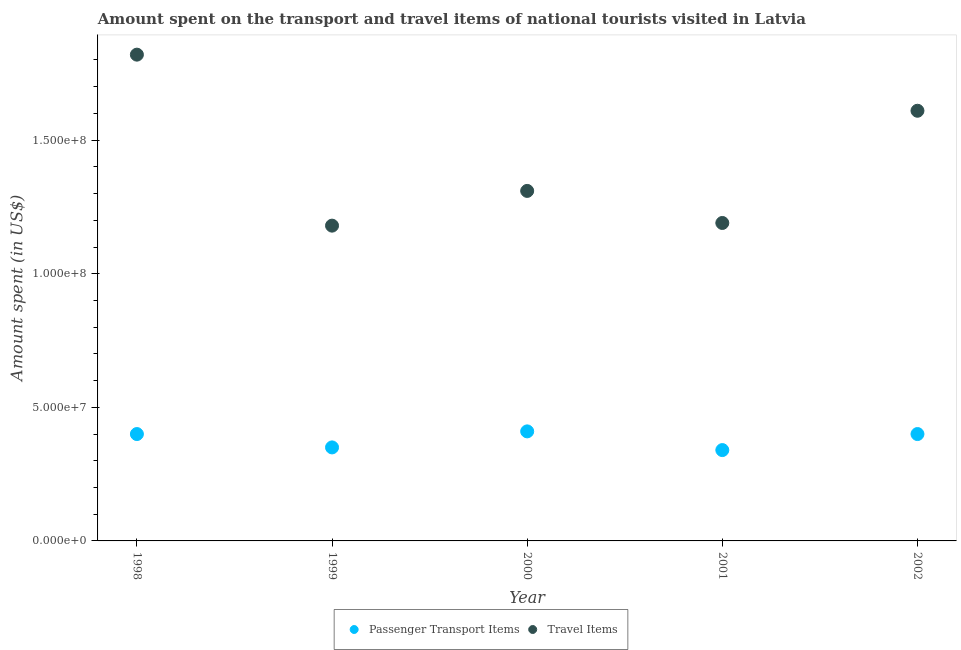How many different coloured dotlines are there?
Ensure brevity in your answer.  2. Is the number of dotlines equal to the number of legend labels?
Offer a terse response. Yes. What is the amount spent on passenger transport items in 2000?
Keep it short and to the point. 4.10e+07. Across all years, what is the maximum amount spent on passenger transport items?
Keep it short and to the point. 4.10e+07. Across all years, what is the minimum amount spent on passenger transport items?
Provide a succinct answer. 3.40e+07. What is the total amount spent on passenger transport items in the graph?
Your answer should be very brief. 1.90e+08. What is the difference between the amount spent on passenger transport items in 1999 and that in 2002?
Your response must be concise. -5.00e+06. What is the difference between the amount spent on passenger transport items in 2001 and the amount spent in travel items in 2002?
Keep it short and to the point. -1.27e+08. What is the average amount spent on passenger transport items per year?
Your answer should be very brief. 3.80e+07. In the year 2001, what is the difference between the amount spent in travel items and amount spent on passenger transport items?
Give a very brief answer. 8.50e+07. Is the difference between the amount spent in travel items in 1999 and 2002 greater than the difference between the amount spent on passenger transport items in 1999 and 2002?
Offer a terse response. No. What is the difference between the highest and the lowest amount spent in travel items?
Keep it short and to the point. 6.40e+07. Is the sum of the amount spent in travel items in 1999 and 2000 greater than the maximum amount spent on passenger transport items across all years?
Make the answer very short. Yes. Does the amount spent on passenger transport items monotonically increase over the years?
Provide a succinct answer. No. What is the difference between two consecutive major ticks on the Y-axis?
Provide a succinct answer. 5.00e+07. Does the graph contain grids?
Give a very brief answer. No. How many legend labels are there?
Offer a terse response. 2. How are the legend labels stacked?
Your answer should be compact. Horizontal. What is the title of the graph?
Give a very brief answer. Amount spent on the transport and travel items of national tourists visited in Latvia. Does "Export" appear as one of the legend labels in the graph?
Provide a succinct answer. No. What is the label or title of the X-axis?
Ensure brevity in your answer.  Year. What is the label or title of the Y-axis?
Provide a succinct answer. Amount spent (in US$). What is the Amount spent (in US$) of Passenger Transport Items in 1998?
Offer a very short reply. 4.00e+07. What is the Amount spent (in US$) of Travel Items in 1998?
Offer a terse response. 1.82e+08. What is the Amount spent (in US$) of Passenger Transport Items in 1999?
Offer a very short reply. 3.50e+07. What is the Amount spent (in US$) in Travel Items in 1999?
Your answer should be compact. 1.18e+08. What is the Amount spent (in US$) in Passenger Transport Items in 2000?
Your answer should be very brief. 4.10e+07. What is the Amount spent (in US$) in Travel Items in 2000?
Provide a succinct answer. 1.31e+08. What is the Amount spent (in US$) of Passenger Transport Items in 2001?
Your answer should be compact. 3.40e+07. What is the Amount spent (in US$) in Travel Items in 2001?
Keep it short and to the point. 1.19e+08. What is the Amount spent (in US$) in Passenger Transport Items in 2002?
Provide a succinct answer. 4.00e+07. What is the Amount spent (in US$) of Travel Items in 2002?
Give a very brief answer. 1.61e+08. Across all years, what is the maximum Amount spent (in US$) of Passenger Transport Items?
Provide a succinct answer. 4.10e+07. Across all years, what is the maximum Amount spent (in US$) in Travel Items?
Provide a succinct answer. 1.82e+08. Across all years, what is the minimum Amount spent (in US$) in Passenger Transport Items?
Provide a succinct answer. 3.40e+07. Across all years, what is the minimum Amount spent (in US$) of Travel Items?
Give a very brief answer. 1.18e+08. What is the total Amount spent (in US$) of Passenger Transport Items in the graph?
Make the answer very short. 1.90e+08. What is the total Amount spent (in US$) of Travel Items in the graph?
Your answer should be very brief. 7.11e+08. What is the difference between the Amount spent (in US$) in Travel Items in 1998 and that in 1999?
Ensure brevity in your answer.  6.40e+07. What is the difference between the Amount spent (in US$) in Travel Items in 1998 and that in 2000?
Keep it short and to the point. 5.10e+07. What is the difference between the Amount spent (in US$) in Travel Items in 1998 and that in 2001?
Ensure brevity in your answer.  6.30e+07. What is the difference between the Amount spent (in US$) in Passenger Transport Items in 1998 and that in 2002?
Your answer should be very brief. 0. What is the difference between the Amount spent (in US$) in Travel Items in 1998 and that in 2002?
Ensure brevity in your answer.  2.10e+07. What is the difference between the Amount spent (in US$) in Passenger Transport Items in 1999 and that in 2000?
Provide a short and direct response. -6.00e+06. What is the difference between the Amount spent (in US$) of Travel Items in 1999 and that in 2000?
Offer a very short reply. -1.30e+07. What is the difference between the Amount spent (in US$) in Passenger Transport Items in 1999 and that in 2001?
Your answer should be compact. 1.00e+06. What is the difference between the Amount spent (in US$) in Travel Items in 1999 and that in 2001?
Offer a very short reply. -1.00e+06. What is the difference between the Amount spent (in US$) of Passenger Transport Items in 1999 and that in 2002?
Keep it short and to the point. -5.00e+06. What is the difference between the Amount spent (in US$) in Travel Items in 1999 and that in 2002?
Your response must be concise. -4.30e+07. What is the difference between the Amount spent (in US$) of Passenger Transport Items in 2000 and that in 2001?
Keep it short and to the point. 7.00e+06. What is the difference between the Amount spent (in US$) in Travel Items in 2000 and that in 2001?
Your answer should be compact. 1.20e+07. What is the difference between the Amount spent (in US$) of Travel Items in 2000 and that in 2002?
Your response must be concise. -3.00e+07. What is the difference between the Amount spent (in US$) in Passenger Transport Items in 2001 and that in 2002?
Offer a very short reply. -6.00e+06. What is the difference between the Amount spent (in US$) of Travel Items in 2001 and that in 2002?
Provide a short and direct response. -4.20e+07. What is the difference between the Amount spent (in US$) in Passenger Transport Items in 1998 and the Amount spent (in US$) in Travel Items in 1999?
Ensure brevity in your answer.  -7.80e+07. What is the difference between the Amount spent (in US$) in Passenger Transport Items in 1998 and the Amount spent (in US$) in Travel Items in 2000?
Your answer should be very brief. -9.10e+07. What is the difference between the Amount spent (in US$) of Passenger Transport Items in 1998 and the Amount spent (in US$) of Travel Items in 2001?
Your answer should be very brief. -7.90e+07. What is the difference between the Amount spent (in US$) in Passenger Transport Items in 1998 and the Amount spent (in US$) in Travel Items in 2002?
Your answer should be very brief. -1.21e+08. What is the difference between the Amount spent (in US$) in Passenger Transport Items in 1999 and the Amount spent (in US$) in Travel Items in 2000?
Offer a very short reply. -9.60e+07. What is the difference between the Amount spent (in US$) of Passenger Transport Items in 1999 and the Amount spent (in US$) of Travel Items in 2001?
Provide a succinct answer. -8.40e+07. What is the difference between the Amount spent (in US$) of Passenger Transport Items in 1999 and the Amount spent (in US$) of Travel Items in 2002?
Give a very brief answer. -1.26e+08. What is the difference between the Amount spent (in US$) in Passenger Transport Items in 2000 and the Amount spent (in US$) in Travel Items in 2001?
Your answer should be very brief. -7.80e+07. What is the difference between the Amount spent (in US$) of Passenger Transport Items in 2000 and the Amount spent (in US$) of Travel Items in 2002?
Your answer should be compact. -1.20e+08. What is the difference between the Amount spent (in US$) in Passenger Transport Items in 2001 and the Amount spent (in US$) in Travel Items in 2002?
Give a very brief answer. -1.27e+08. What is the average Amount spent (in US$) of Passenger Transport Items per year?
Provide a short and direct response. 3.80e+07. What is the average Amount spent (in US$) of Travel Items per year?
Provide a short and direct response. 1.42e+08. In the year 1998, what is the difference between the Amount spent (in US$) of Passenger Transport Items and Amount spent (in US$) of Travel Items?
Provide a short and direct response. -1.42e+08. In the year 1999, what is the difference between the Amount spent (in US$) of Passenger Transport Items and Amount spent (in US$) of Travel Items?
Provide a succinct answer. -8.30e+07. In the year 2000, what is the difference between the Amount spent (in US$) of Passenger Transport Items and Amount spent (in US$) of Travel Items?
Provide a short and direct response. -9.00e+07. In the year 2001, what is the difference between the Amount spent (in US$) of Passenger Transport Items and Amount spent (in US$) of Travel Items?
Your response must be concise. -8.50e+07. In the year 2002, what is the difference between the Amount spent (in US$) in Passenger Transport Items and Amount spent (in US$) in Travel Items?
Provide a succinct answer. -1.21e+08. What is the ratio of the Amount spent (in US$) in Passenger Transport Items in 1998 to that in 1999?
Provide a short and direct response. 1.14. What is the ratio of the Amount spent (in US$) in Travel Items in 1998 to that in 1999?
Keep it short and to the point. 1.54. What is the ratio of the Amount spent (in US$) of Passenger Transport Items in 1998 to that in 2000?
Provide a short and direct response. 0.98. What is the ratio of the Amount spent (in US$) of Travel Items in 1998 to that in 2000?
Your answer should be compact. 1.39. What is the ratio of the Amount spent (in US$) of Passenger Transport Items in 1998 to that in 2001?
Keep it short and to the point. 1.18. What is the ratio of the Amount spent (in US$) of Travel Items in 1998 to that in 2001?
Your answer should be very brief. 1.53. What is the ratio of the Amount spent (in US$) in Travel Items in 1998 to that in 2002?
Give a very brief answer. 1.13. What is the ratio of the Amount spent (in US$) in Passenger Transport Items in 1999 to that in 2000?
Your response must be concise. 0.85. What is the ratio of the Amount spent (in US$) of Travel Items in 1999 to that in 2000?
Offer a terse response. 0.9. What is the ratio of the Amount spent (in US$) in Passenger Transport Items in 1999 to that in 2001?
Your response must be concise. 1.03. What is the ratio of the Amount spent (in US$) of Travel Items in 1999 to that in 2001?
Provide a short and direct response. 0.99. What is the ratio of the Amount spent (in US$) in Travel Items in 1999 to that in 2002?
Provide a succinct answer. 0.73. What is the ratio of the Amount spent (in US$) of Passenger Transport Items in 2000 to that in 2001?
Give a very brief answer. 1.21. What is the ratio of the Amount spent (in US$) of Travel Items in 2000 to that in 2001?
Provide a short and direct response. 1.1. What is the ratio of the Amount spent (in US$) in Passenger Transport Items in 2000 to that in 2002?
Give a very brief answer. 1.02. What is the ratio of the Amount spent (in US$) of Travel Items in 2000 to that in 2002?
Provide a short and direct response. 0.81. What is the ratio of the Amount spent (in US$) of Passenger Transport Items in 2001 to that in 2002?
Make the answer very short. 0.85. What is the ratio of the Amount spent (in US$) of Travel Items in 2001 to that in 2002?
Provide a short and direct response. 0.74. What is the difference between the highest and the second highest Amount spent (in US$) in Passenger Transport Items?
Offer a very short reply. 1.00e+06. What is the difference between the highest and the second highest Amount spent (in US$) of Travel Items?
Keep it short and to the point. 2.10e+07. What is the difference between the highest and the lowest Amount spent (in US$) of Passenger Transport Items?
Offer a very short reply. 7.00e+06. What is the difference between the highest and the lowest Amount spent (in US$) of Travel Items?
Ensure brevity in your answer.  6.40e+07. 